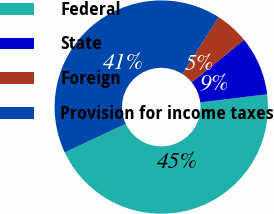Convert chart to OTSL. <chart><loc_0><loc_0><loc_500><loc_500><pie_chart><fcel>Federal<fcel>State<fcel>Foreign<fcel>Provision for income taxes<nl><fcel>44.93%<fcel>8.95%<fcel>5.07%<fcel>41.05%<nl></chart> 